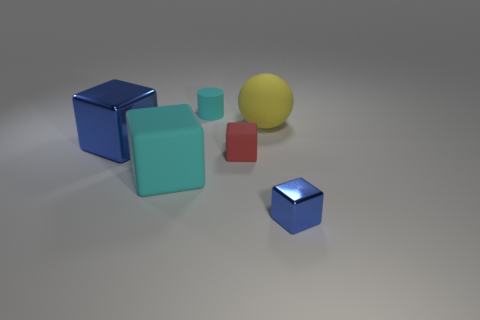Can you explain the material of the objects in the image? The objects in the image seem to have a reflective surface, indicating they could be made of a material like polished metal or plastic with a high sheen. This reflective quality gives them a shiny appearance, enhancing their visual impact. 